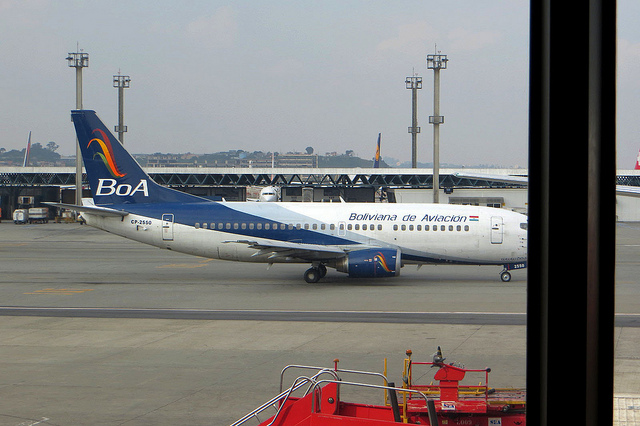<image>What substance-abuse recovery organization is represented by the same letters on the plane's tail? I don't know what substance-abuse recovery organization is represented by the same letters on the plane's tail. It could be alcoholics anon or boa or aa or Bank of America. What substance-abuse recovery organization is represented by the same letters on the plane's tail? I am not aware of the substance-abuse recovery organization represented by the same letters on the plane's tail. It can be either 'boa', 'alcoholics anon', or 'aa'. 